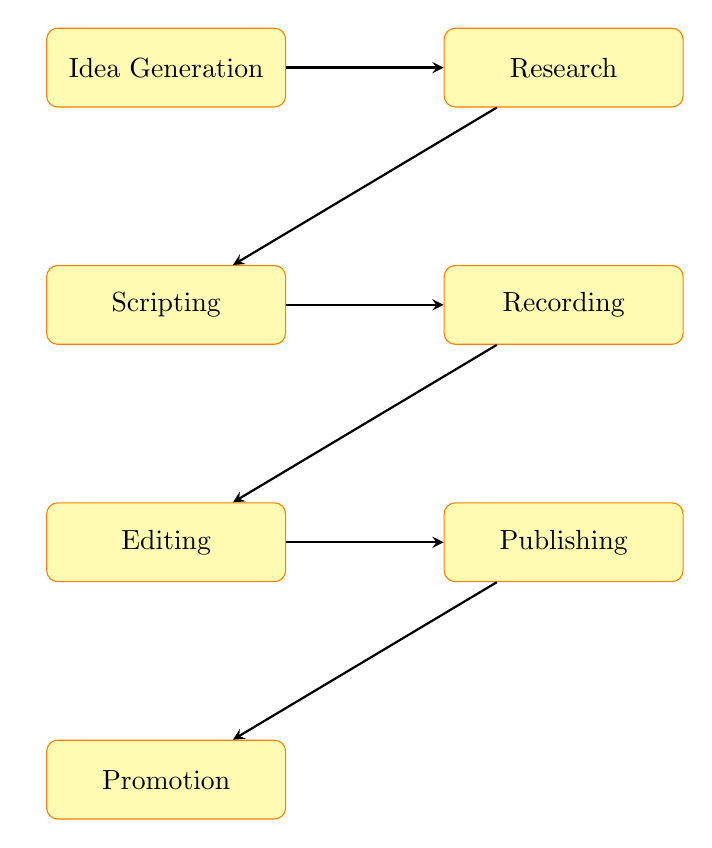What is the first stage in the podcast production process? The first stage in the podcast production process, as shown in the diagram, is "Idea Generation." This can be identified by locating the topmost node in the flow chart.
Answer: Idea Generation How many total stages are there in producing a podcast episode? By counting each node in the diagram, we find that there are seven stages: Idea Generation, Research, Scripting, Recording, Editing, Publishing, and Promotion.
Answer: Seven What is the last stage of podcast production? The last stage of the podcast production process is identified by the bottom node in the flow chart, which is "Promotion."
Answer: Promotion Which stage comes directly after "Recording"? In the flow chart, "Editing" is the stage that comes immediately after "Recording." This is found by following the arrow that connects "Recording" to the next node below it.
Answer: Editing In which order do "Scripting" and "Research" occur? The diagram shows that "Research" occurs before "Scripting," as "Research" is positioned to the right of "Idea Generation," and "Scripting" is placed below "Idea Generation," indicating that it follows after "Research."
Answer: Research, Scripting What do "Editing" and "Publishing" have in common? Both "Editing" and "Publishing" are stages that directly follow the "Recording" stage. This can be observed by locating their positions in relation to "Recording," where they are both subsequent steps in the process.
Answer: They come after Recording What is the main purpose of the "Research" stage? The purpose of the "Research" stage, as indicated in the diagram, is to "Gather information and resources related to your chosen topic." This is directly stated in the description of the "Research" node in the chart.
Answer: Gather information and resources What type of diagram is this? This diagram is classified as a flow chart, which is specifically designed to illustrate the steps and stages in producing a podcast episode. The nodes and arrows visually represent the sequential process involved.
Answer: Flow chart 